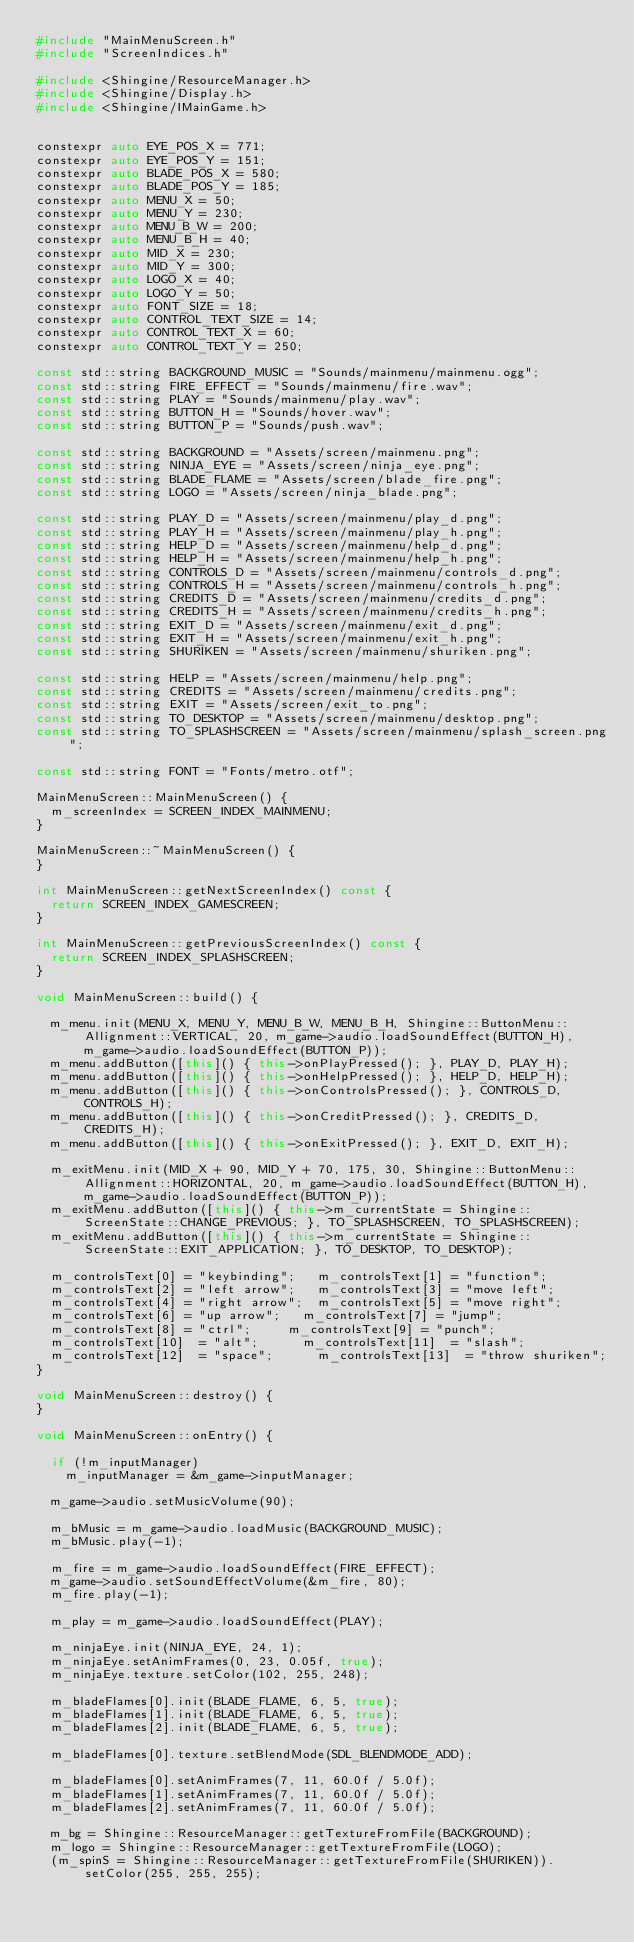Convert code to text. <code><loc_0><loc_0><loc_500><loc_500><_C++_>#include "MainMenuScreen.h"
#include "ScreenIndices.h"

#include <Shingine/ResourceManager.h>
#include <Shingine/Display.h>
#include <Shingine/IMainGame.h>


constexpr auto EYE_POS_X = 771;
constexpr auto EYE_POS_Y = 151;
constexpr auto BLADE_POS_X = 580;
constexpr auto BLADE_POS_Y = 185;
constexpr auto MENU_X = 50;
constexpr auto MENU_Y = 230;
constexpr auto MENU_B_W = 200;
constexpr auto MENU_B_H = 40;
constexpr auto MID_X = 230;
constexpr auto MID_Y = 300;
constexpr auto LOGO_X = 40;
constexpr auto LOGO_Y = 50;
constexpr auto FONT_SIZE = 18;
constexpr auto CONTROL_TEXT_SIZE = 14;
constexpr auto CONTROL_TEXT_X = 60;
constexpr auto CONTROL_TEXT_Y = 250;

const std::string BACKGROUND_MUSIC = "Sounds/mainmenu/mainmenu.ogg";
const std::string FIRE_EFFECT = "Sounds/mainmenu/fire.wav";
const std::string PLAY = "Sounds/mainmenu/play.wav";
const std::string BUTTON_H = "Sounds/hover.wav";
const std::string BUTTON_P = "Sounds/push.wav";

const std::string BACKGROUND = "Assets/screen/mainmenu.png";
const std::string NINJA_EYE = "Assets/screen/ninja_eye.png";
const std::string BLADE_FLAME = "Assets/screen/blade_fire.png";
const std::string LOGO = "Assets/screen/ninja_blade.png";

const std::string PLAY_D = "Assets/screen/mainmenu/play_d.png";
const std::string PLAY_H = "Assets/screen/mainmenu/play_h.png";
const std::string HELP_D = "Assets/screen/mainmenu/help_d.png";
const std::string HELP_H = "Assets/screen/mainmenu/help_h.png";
const std::string CONTROLS_D = "Assets/screen/mainmenu/controls_d.png";
const std::string CONTROLS_H = "Assets/screen/mainmenu/controls_h.png";
const std::string CREDITS_D = "Assets/screen/mainmenu/credits_d.png";
const std::string CREDITS_H = "Assets/screen/mainmenu/credits_h.png";
const std::string EXIT_D = "Assets/screen/mainmenu/exit_d.png";
const std::string EXIT_H = "Assets/screen/mainmenu/exit_h.png";
const std::string SHURIKEN = "Assets/screen/mainmenu/shuriken.png";

const std::string HELP = "Assets/screen/mainmenu/help.png";
const std::string CREDITS = "Assets/screen/mainmenu/credits.png";
const std::string EXIT = "Assets/screen/exit_to.png";
const std::string TO_DESKTOP = "Assets/screen/mainmenu/desktop.png";
const std::string TO_SPLASHSCREEN = "Assets/screen/mainmenu/splash_screen.png";

const std::string FONT = "Fonts/metro.otf";

MainMenuScreen::MainMenuScreen() {
	m_screenIndex = SCREEN_INDEX_MAINMENU;
}

MainMenuScreen::~MainMenuScreen() {
}

int MainMenuScreen::getNextScreenIndex() const {
	return SCREEN_INDEX_GAMESCREEN;
}

int MainMenuScreen::getPreviousScreenIndex() const {
	return SCREEN_INDEX_SPLASHSCREEN;
}

void MainMenuScreen::build() {
	
	m_menu.init(MENU_X, MENU_Y, MENU_B_W, MENU_B_H, Shingine::ButtonMenu::Allignment::VERTICAL, 20, m_game->audio.loadSoundEffect(BUTTON_H), m_game->audio.loadSoundEffect(BUTTON_P));
	m_menu.addButton([this]() { this->onPlayPressed(); }, PLAY_D, PLAY_H);
	m_menu.addButton([this]() { this->onHelpPressed(); }, HELP_D, HELP_H);
	m_menu.addButton([this]() { this->onControlsPressed(); }, CONTROLS_D, CONTROLS_H);
	m_menu.addButton([this]() { this->onCreditPressed(); }, CREDITS_D, CREDITS_H);
	m_menu.addButton([this]() { this->onExitPressed(); }, EXIT_D, EXIT_H);

	m_exitMenu.init(MID_X + 90, MID_Y + 70, 175, 30, Shingine::ButtonMenu::Allignment::HORIZONTAL, 20, m_game->audio.loadSoundEffect(BUTTON_H), m_game->audio.loadSoundEffect(BUTTON_P));
	m_exitMenu.addButton([this]() { this->m_currentState = Shingine::ScreenState::CHANGE_PREVIOUS; }, TO_SPLASHSCREEN, TO_SPLASHSCREEN);
	m_exitMenu.addButton([this]() { this->m_currentState = Shingine::ScreenState::EXIT_APPLICATION; }, TO_DESKTOP, TO_DESKTOP);

	m_controlsText[0]	= "keybinding";		m_controlsText[1]	= "function";
	m_controlsText[2]	= "left arrow";		m_controlsText[3]	= "move left";
	m_controlsText[4]	= "right arrow";	m_controlsText[5]	= "move right";
	m_controlsText[6]	= "up arrow";		m_controlsText[7]	= "jump";
	m_controlsText[8]	= "ctrl";			m_controlsText[9]	= "punch";
	m_controlsText[10]	= "alt";			m_controlsText[11]	= "slash";
	m_controlsText[12]	= "space";			m_controlsText[13]	= "throw shuriken";
}	

void MainMenuScreen::destroy() {
}

void MainMenuScreen::onEntry() {

	if (!m_inputManager)
		m_inputManager = &m_game->inputManager;

	m_game->audio.setMusicVolume(90);
	
	m_bMusic = m_game->audio.loadMusic(BACKGROUND_MUSIC);
	m_bMusic.play(-1);

	m_fire = m_game->audio.loadSoundEffect(FIRE_EFFECT);
	m_game->audio.setSoundEffectVolume(&m_fire, 80);
	m_fire.play(-1);
	
	m_play = m_game->audio.loadSoundEffect(PLAY);

	m_ninjaEye.init(NINJA_EYE, 24, 1);
	m_ninjaEye.setAnimFrames(0, 23, 0.05f, true);
	m_ninjaEye.texture.setColor(102, 255, 248);

	m_bladeFlames[0].init(BLADE_FLAME, 6, 5, true);
	m_bladeFlames[1].init(BLADE_FLAME, 6, 5, true);
	m_bladeFlames[2].init(BLADE_FLAME, 6, 5, true);

	m_bladeFlames[0].texture.setBlendMode(SDL_BLENDMODE_ADD);

	m_bladeFlames[0].setAnimFrames(7, 11, 60.0f / 5.0f);
	m_bladeFlames[1].setAnimFrames(7, 11, 60.0f / 5.0f);
	m_bladeFlames[2].setAnimFrames(7, 11, 60.0f / 5.0f);

	m_bg = Shingine::ResourceManager::getTextureFromFile(BACKGROUND);
	m_logo = Shingine::ResourceManager::getTextureFromFile(LOGO);
	(m_spinS = Shingine::ResourceManager::getTextureFromFile(SHURIKEN)).setColor(255, 255, 255);</code> 